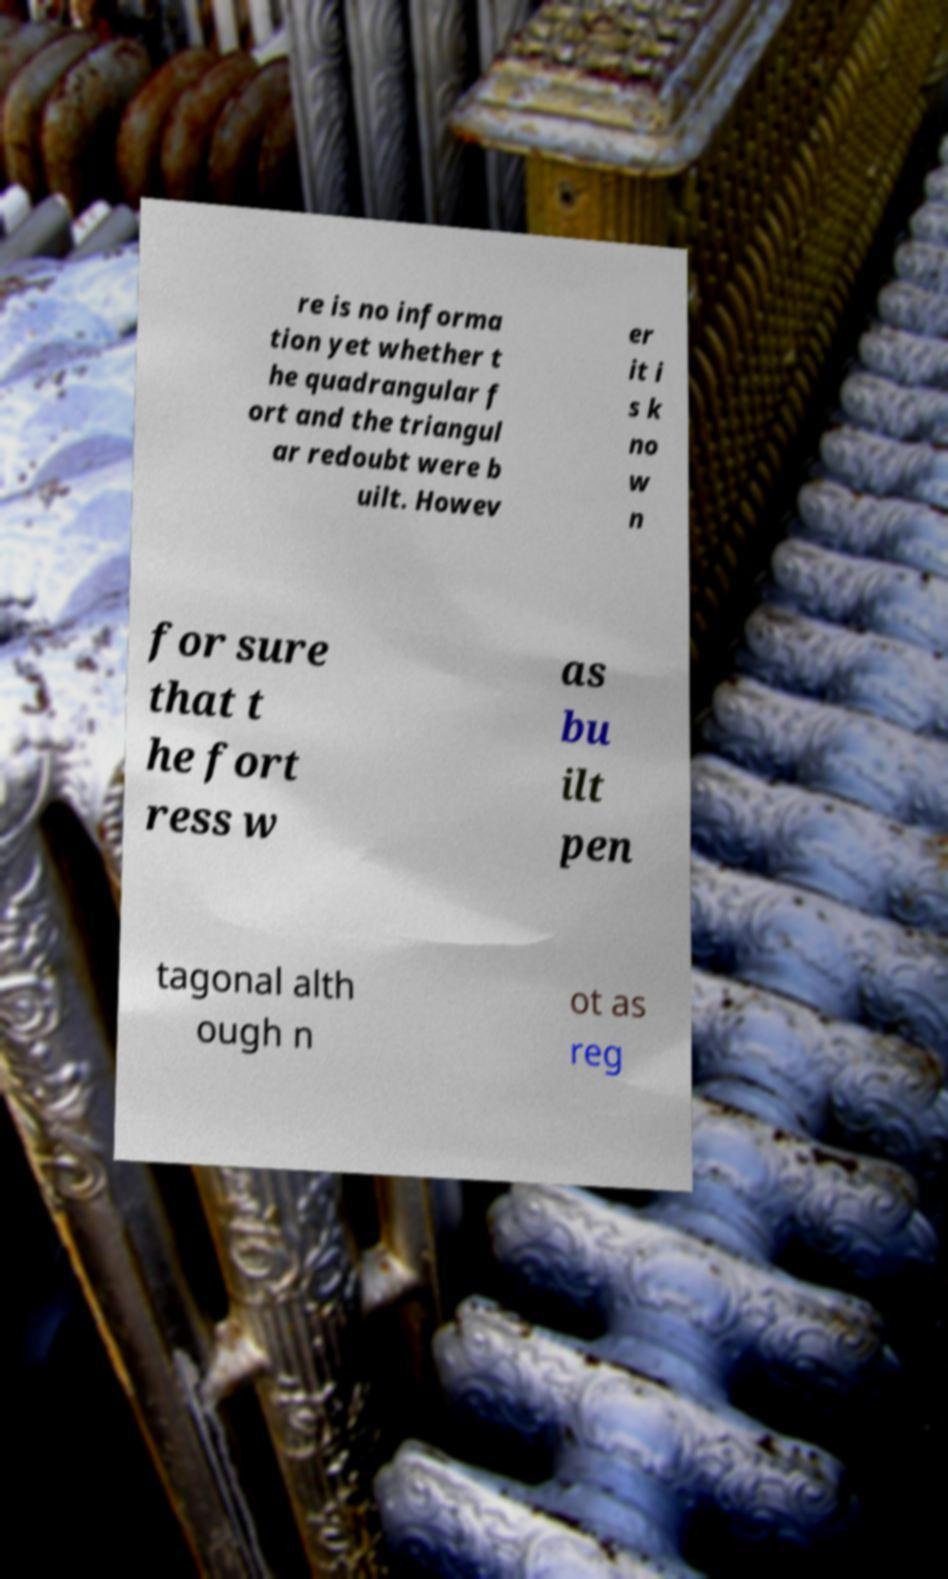Please read and relay the text visible in this image. What does it say? re is no informa tion yet whether t he quadrangular f ort and the triangul ar redoubt were b uilt. Howev er it i s k no w n for sure that t he fort ress w as bu ilt pen tagonal alth ough n ot as reg 